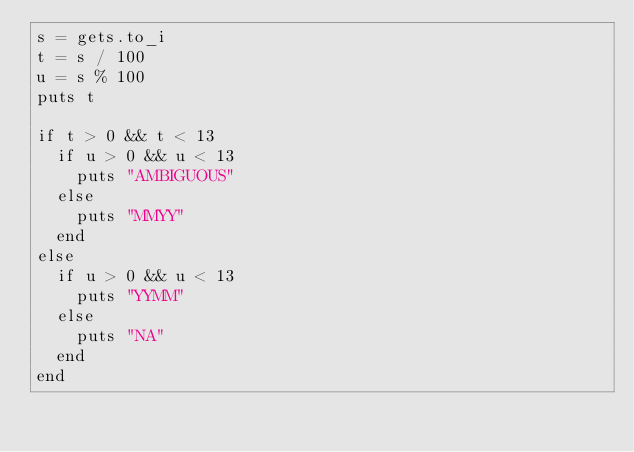Convert code to text. <code><loc_0><loc_0><loc_500><loc_500><_Ruby_>s = gets.to_i
t = s / 100
u = s % 100
puts t

if t > 0 && t < 13
  if u > 0 && u < 13
    puts "AMBIGUOUS"
  else
    puts "MMYY"
  end
else
  if u > 0 && u < 13
    puts "YYMM"
  else
    puts "NA"
  end
end</code> 